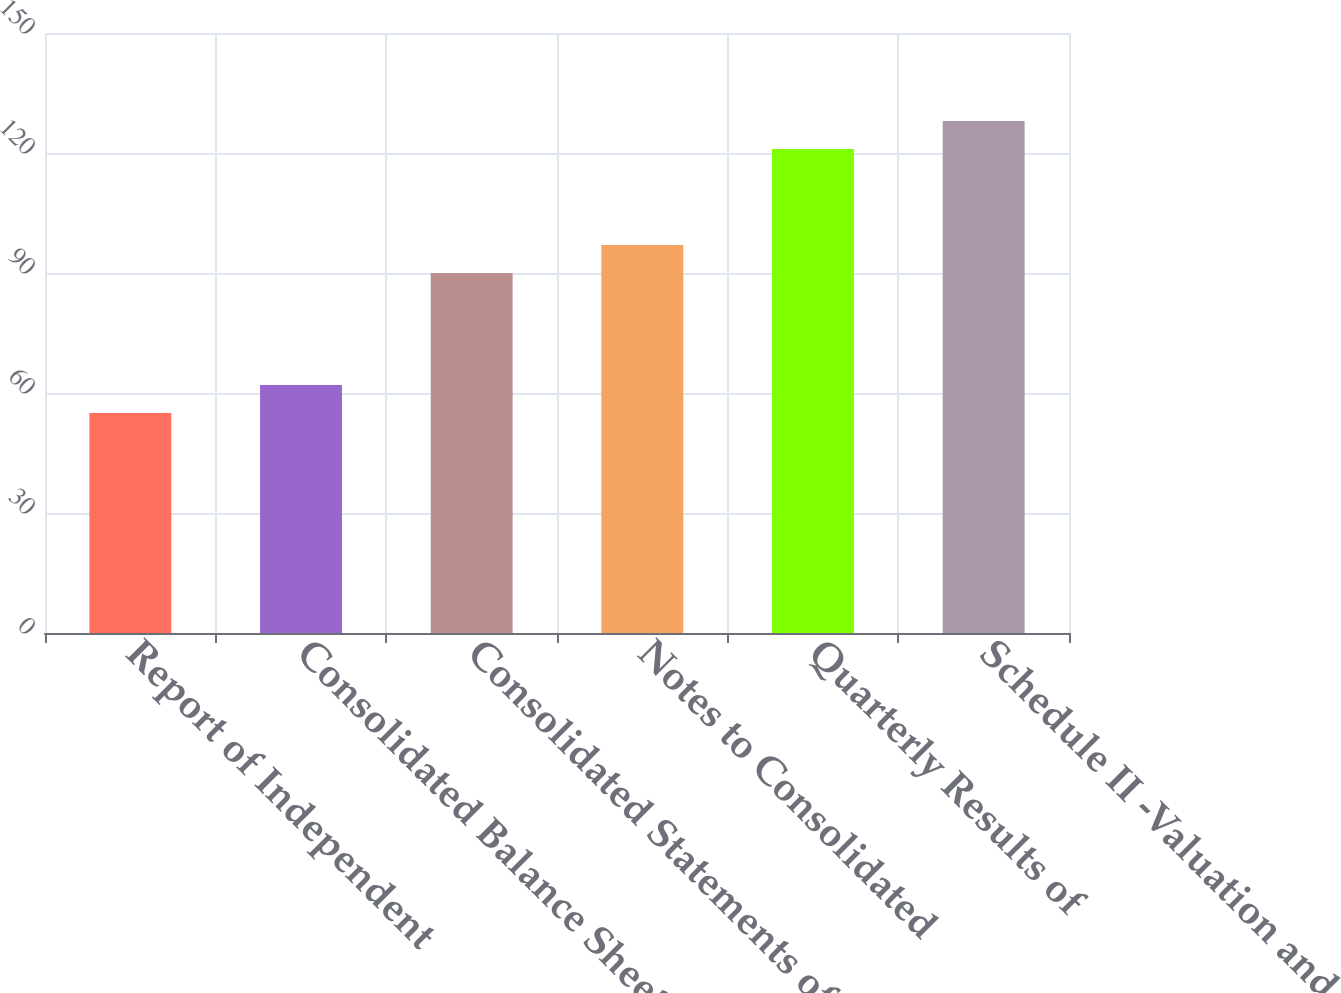Convert chart. <chart><loc_0><loc_0><loc_500><loc_500><bar_chart><fcel>Report of Independent<fcel>Consolidated Balance Sheets at<fcel>Consolidated Statements of<fcel>Notes to Consolidated<fcel>Quarterly Results of<fcel>Schedule II -Valuation and<nl><fcel>55<fcel>62<fcel>90<fcel>97<fcel>121<fcel>128<nl></chart> 